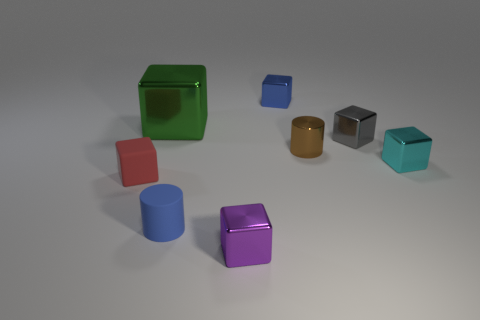What number of metal cubes are the same size as the red matte block?
Offer a very short reply. 4. There is a metal object left of the tiny purple block; is its size the same as the blue object that is left of the purple metal block?
Provide a succinct answer. No. What is the size of the shiny cube on the left side of the purple thing?
Provide a succinct answer. Large. There is a shiny cube to the left of the object that is in front of the tiny matte cylinder; what is its size?
Provide a succinct answer. Large. What is the material of the brown object that is the same size as the cyan thing?
Provide a succinct answer. Metal. Are there any tiny brown metallic objects in front of the tiny blue rubber object?
Make the answer very short. No. Is the number of tiny blue matte cylinders to the right of the tiny blue cube the same as the number of small purple metal cylinders?
Provide a succinct answer. Yes. There is a blue rubber thing that is the same size as the brown cylinder; what is its shape?
Keep it short and to the point. Cylinder. What is the tiny purple block made of?
Provide a short and direct response. Metal. What color is the block that is both left of the tiny rubber cylinder and behind the small cyan object?
Offer a very short reply. Green. 